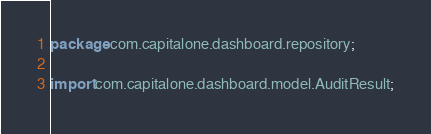Convert code to text. <code><loc_0><loc_0><loc_500><loc_500><_Java_>package com.capitalone.dashboard.repository;

import com.capitalone.dashboard.model.AuditResult;</code> 